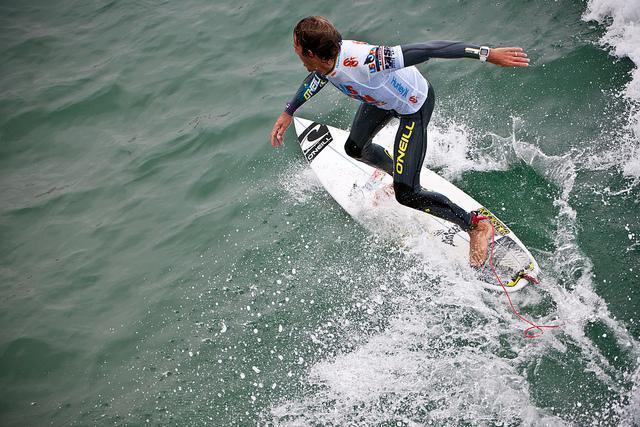How many giraffe are under the blue sky?
Give a very brief answer. 0. 